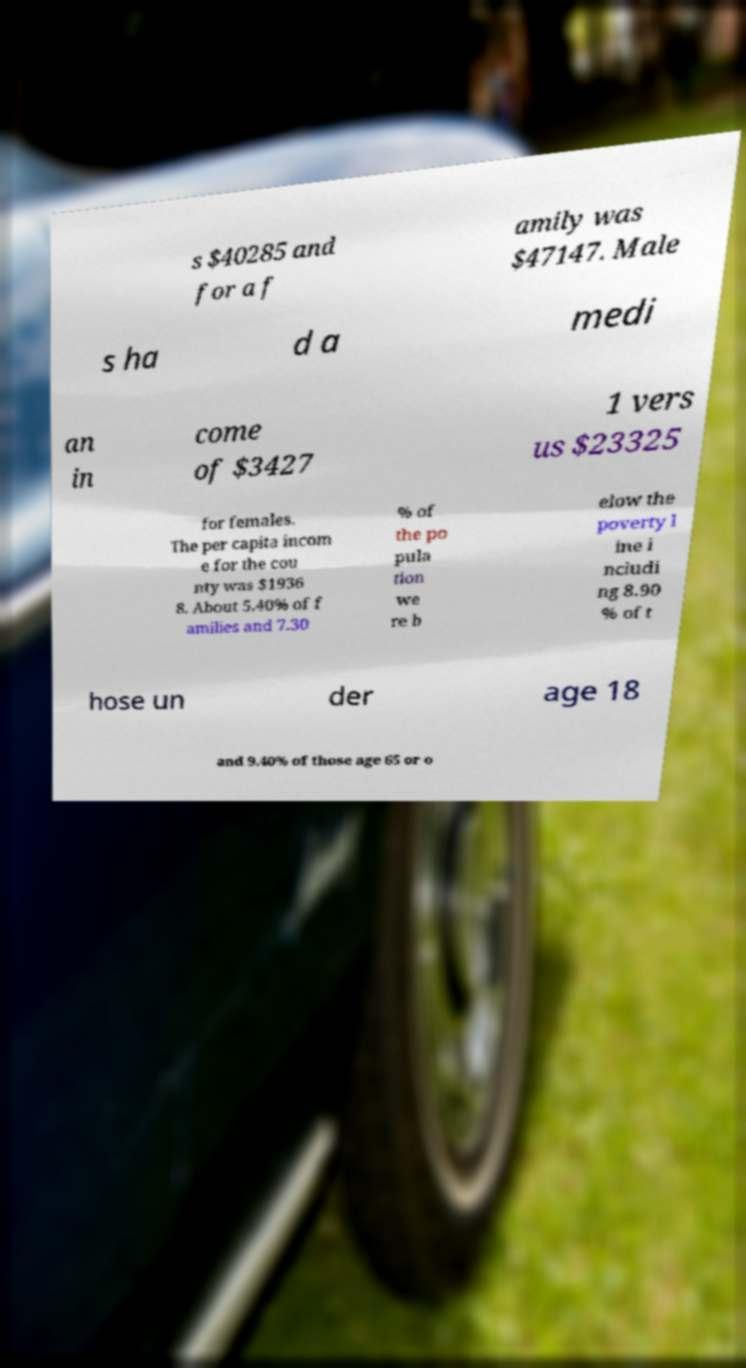What messages or text are displayed in this image? I need them in a readable, typed format. s $40285 and for a f amily was $47147. Male s ha d a medi an in come of $3427 1 vers us $23325 for females. The per capita incom e for the cou nty was $1936 8. About 5.40% of f amilies and 7.30 % of the po pula tion we re b elow the poverty l ine i ncludi ng 8.90 % of t hose un der age 18 and 9.40% of those age 65 or o 